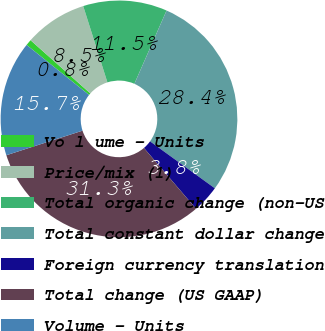<chart> <loc_0><loc_0><loc_500><loc_500><pie_chart><fcel>Vo l ume - Units<fcel>Price/mix (1)<fcel>Total organic change (non-US<fcel>Total constant dollar change<fcel>Foreign currency translation<fcel>Total change (US GAAP)<fcel>Volume - Units<nl><fcel>0.83%<fcel>8.54%<fcel>11.47%<fcel>28.39%<fcel>3.75%<fcel>31.31%<fcel>15.71%<nl></chart> 